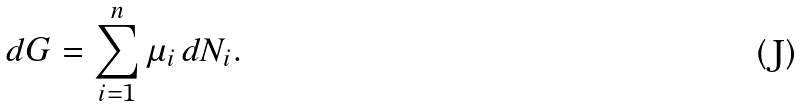Convert formula to latex. <formula><loc_0><loc_0><loc_500><loc_500>d G = \sum _ { i = 1 } ^ { n } \mu _ { i } \, d N _ { i } .</formula> 